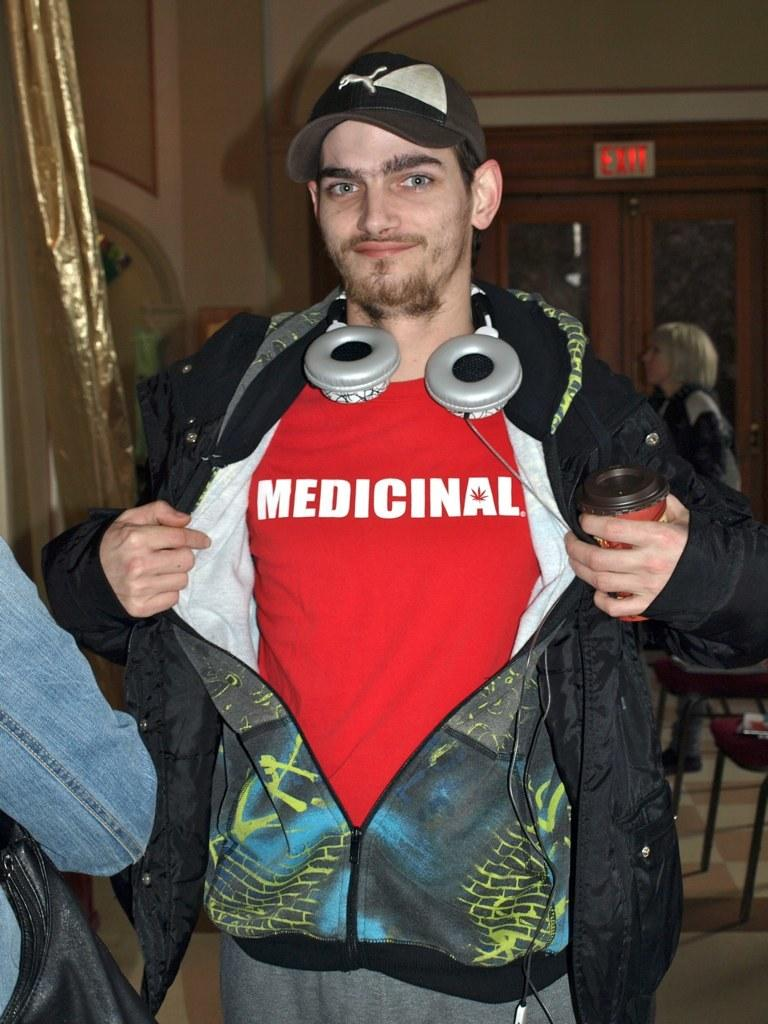What is the person in the image wearing on their upper body? The person is wearing a red shirt and a black jacket. What type of headwear is the person wearing in the image? The person is wearing a black cap. Can you describe the background of the image? There are other people standing in the background. What color is the curtain on the left side of the image? The curtain is gold in color. How does the person in the image blow a screw? There is no screw present in the image, and the person is not performing any action related to blowing a screw. 